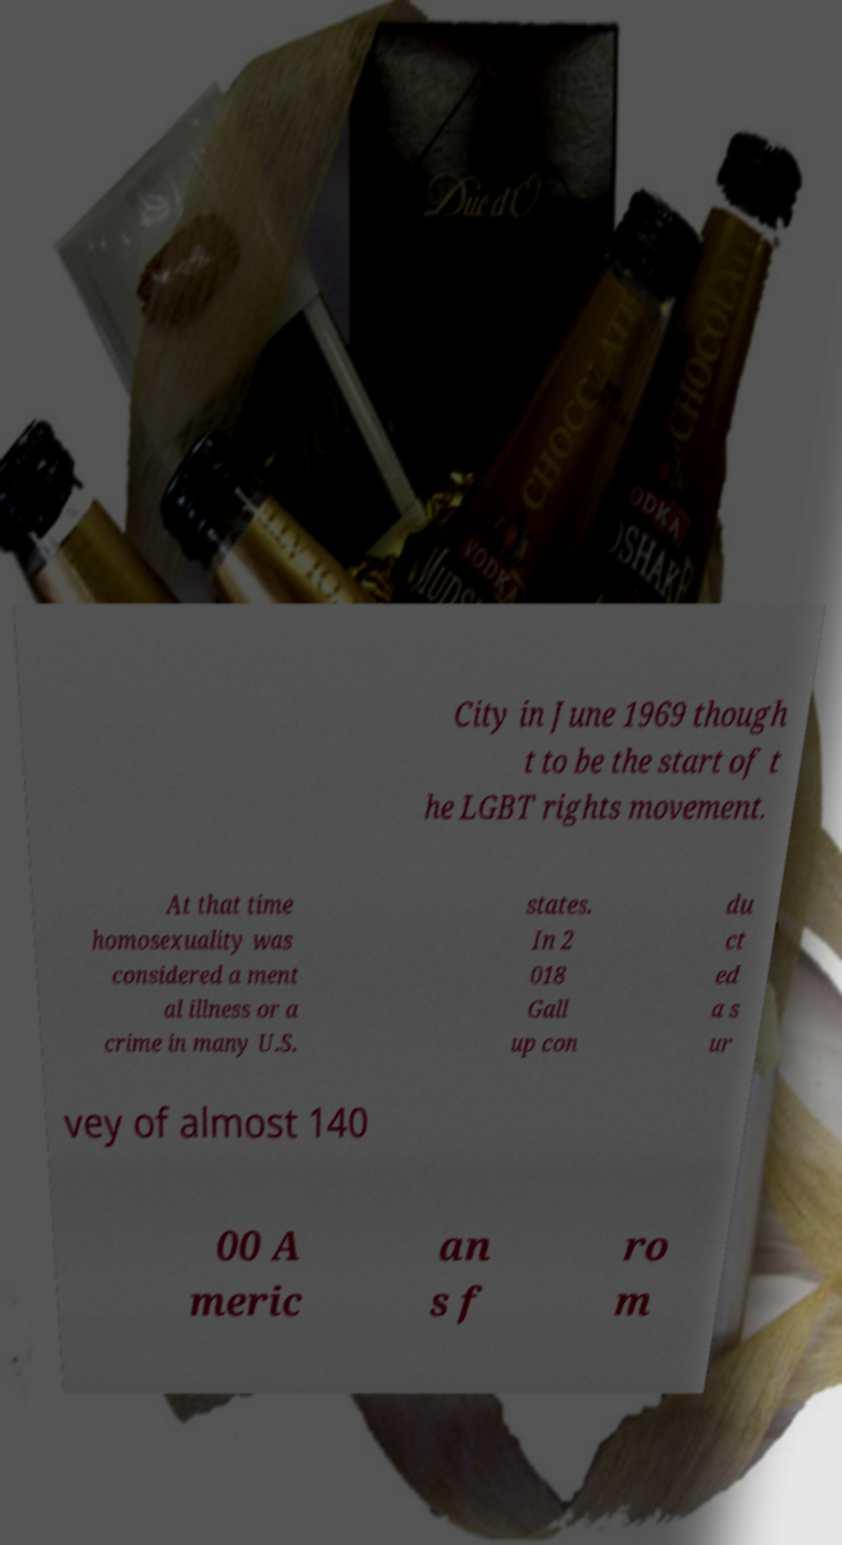Could you extract and type out the text from this image? City in June 1969 though t to be the start of t he LGBT rights movement. At that time homosexuality was considered a ment al illness or a crime in many U.S. states. In 2 018 Gall up con du ct ed a s ur vey of almost 140 00 A meric an s f ro m 